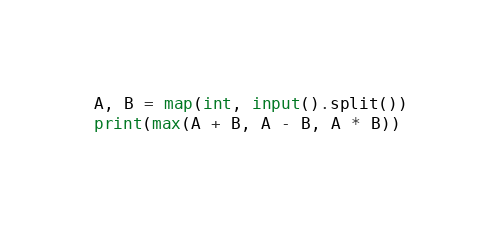Convert code to text. <code><loc_0><loc_0><loc_500><loc_500><_Python_>A, B = map(int, input().split())
print(max(A + B, A - B, A * B))</code> 